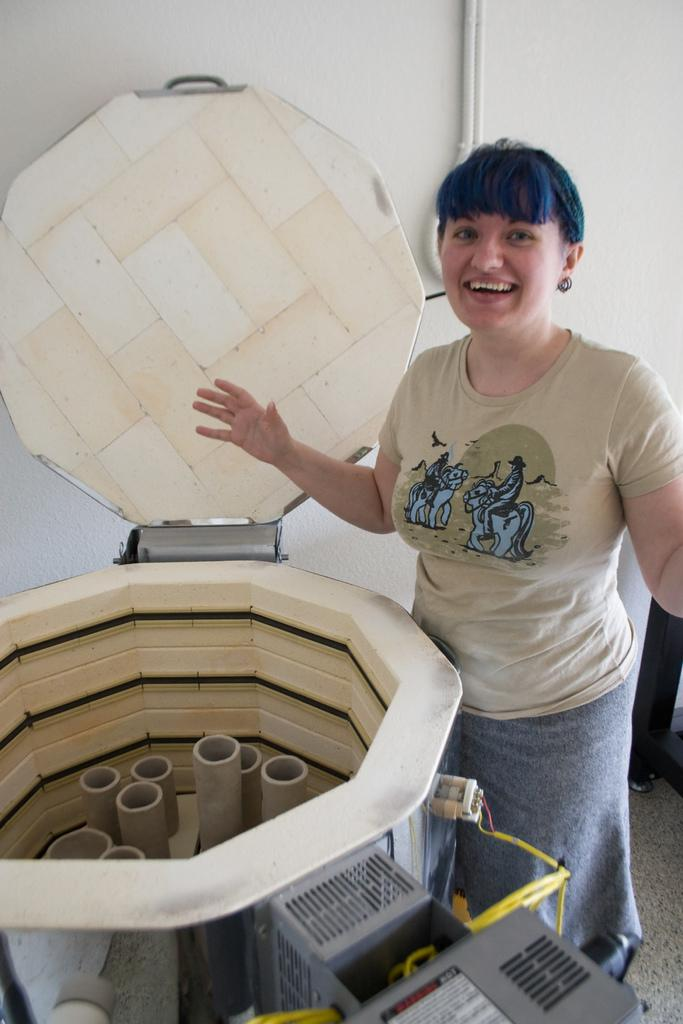Who or what is present in the image? There is a person in the image. What is the person wearing? The person is wearing a dress. What can be seen in front of the person? There is a machine in front of the person. What is visible in the background of the image? There is a white wall in the background of the image. What type of magic is the person performing in the image? There is no indication of magic or any magical activity in the image. 